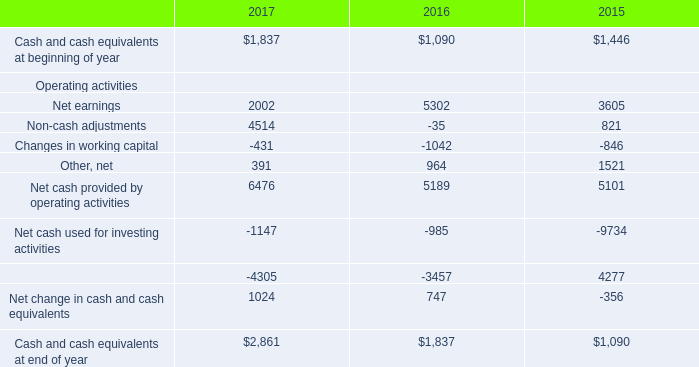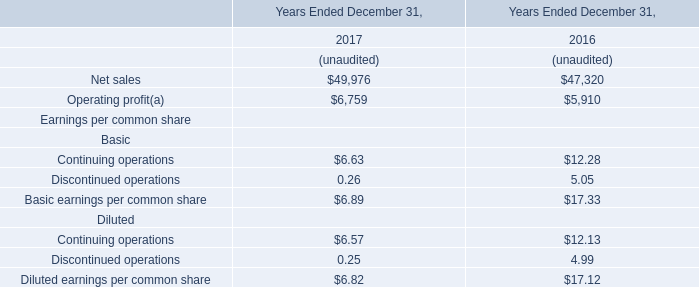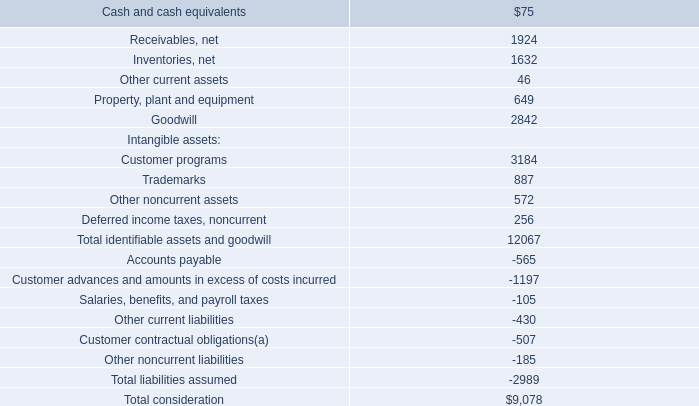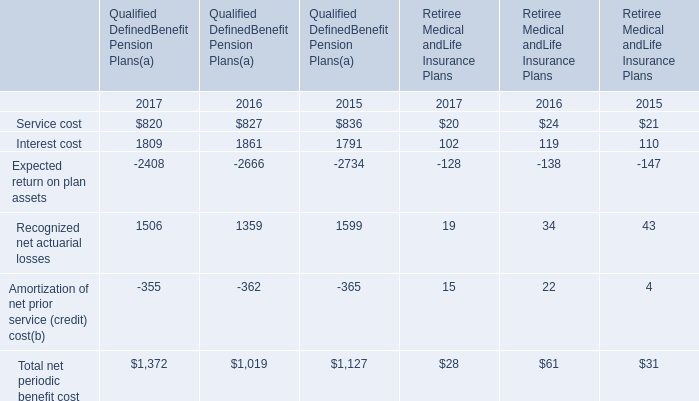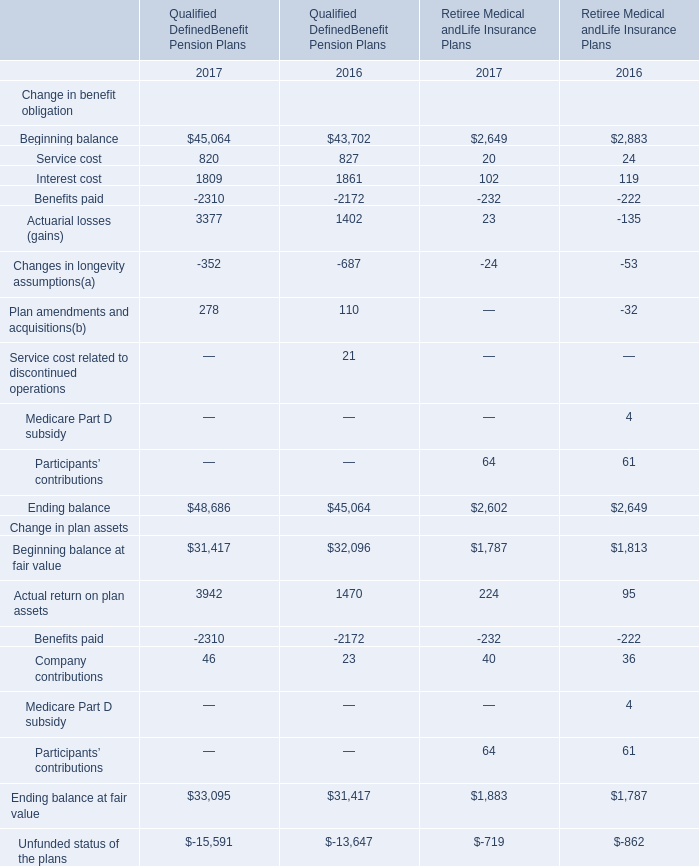What's the sum of all Service cost that are positive in Qualified DefinedBenefit Pension Plans(a) 
Computations: ((820 + 827) + 836)
Answer: 2483.0. 